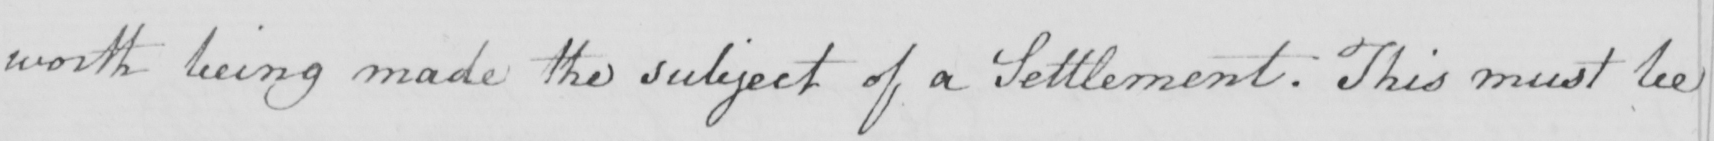Transcribe the text shown in this historical manuscript line. worth being made the subject of a Settlement . This must be 